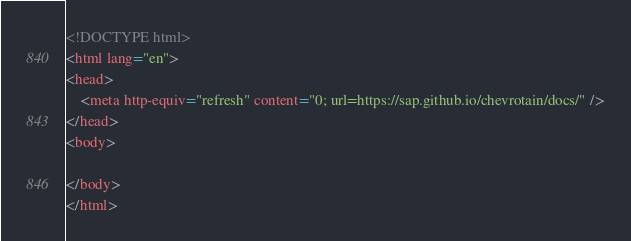Convert code to text. <code><loc_0><loc_0><loc_500><loc_500><_HTML_><!DOCTYPE html>
<html lang="en">
<head>
    <meta http-equiv="refresh" content="0; url=https://sap.github.io/chevrotain/docs/" />
</head>
<body>

</body>
</html>
</code> 